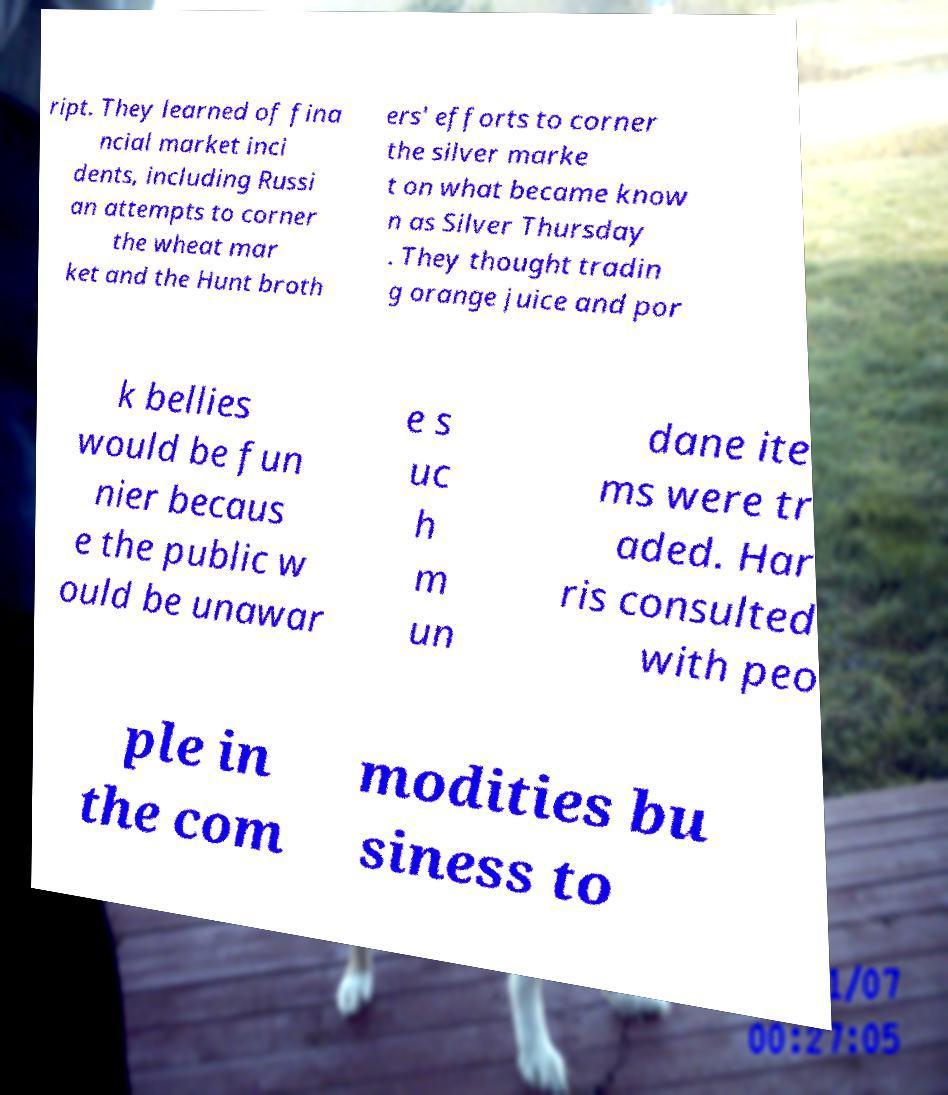Please read and relay the text visible in this image. What does it say? ript. They learned of fina ncial market inci dents, including Russi an attempts to corner the wheat mar ket and the Hunt broth ers' efforts to corner the silver marke t on what became know n as Silver Thursday . They thought tradin g orange juice and por k bellies would be fun nier becaus e the public w ould be unawar e s uc h m un dane ite ms were tr aded. Har ris consulted with peo ple in the com modities bu siness to 